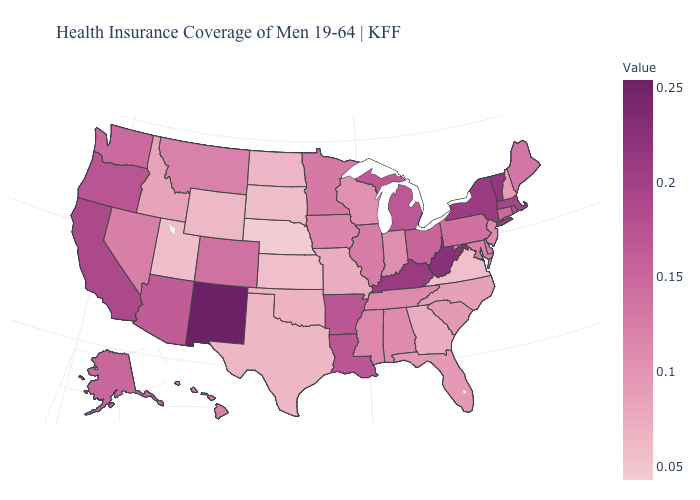Which states have the lowest value in the MidWest?
Short answer required. Nebraska. Does Florida have a higher value than Wyoming?
Be succinct. Yes. Which states hav the highest value in the South?
Quick response, please. West Virginia. Among the states that border Iowa , which have the highest value?
Write a very short answer. Minnesota. Among the states that border Oregon , does California have the highest value?
Write a very short answer. Yes. 